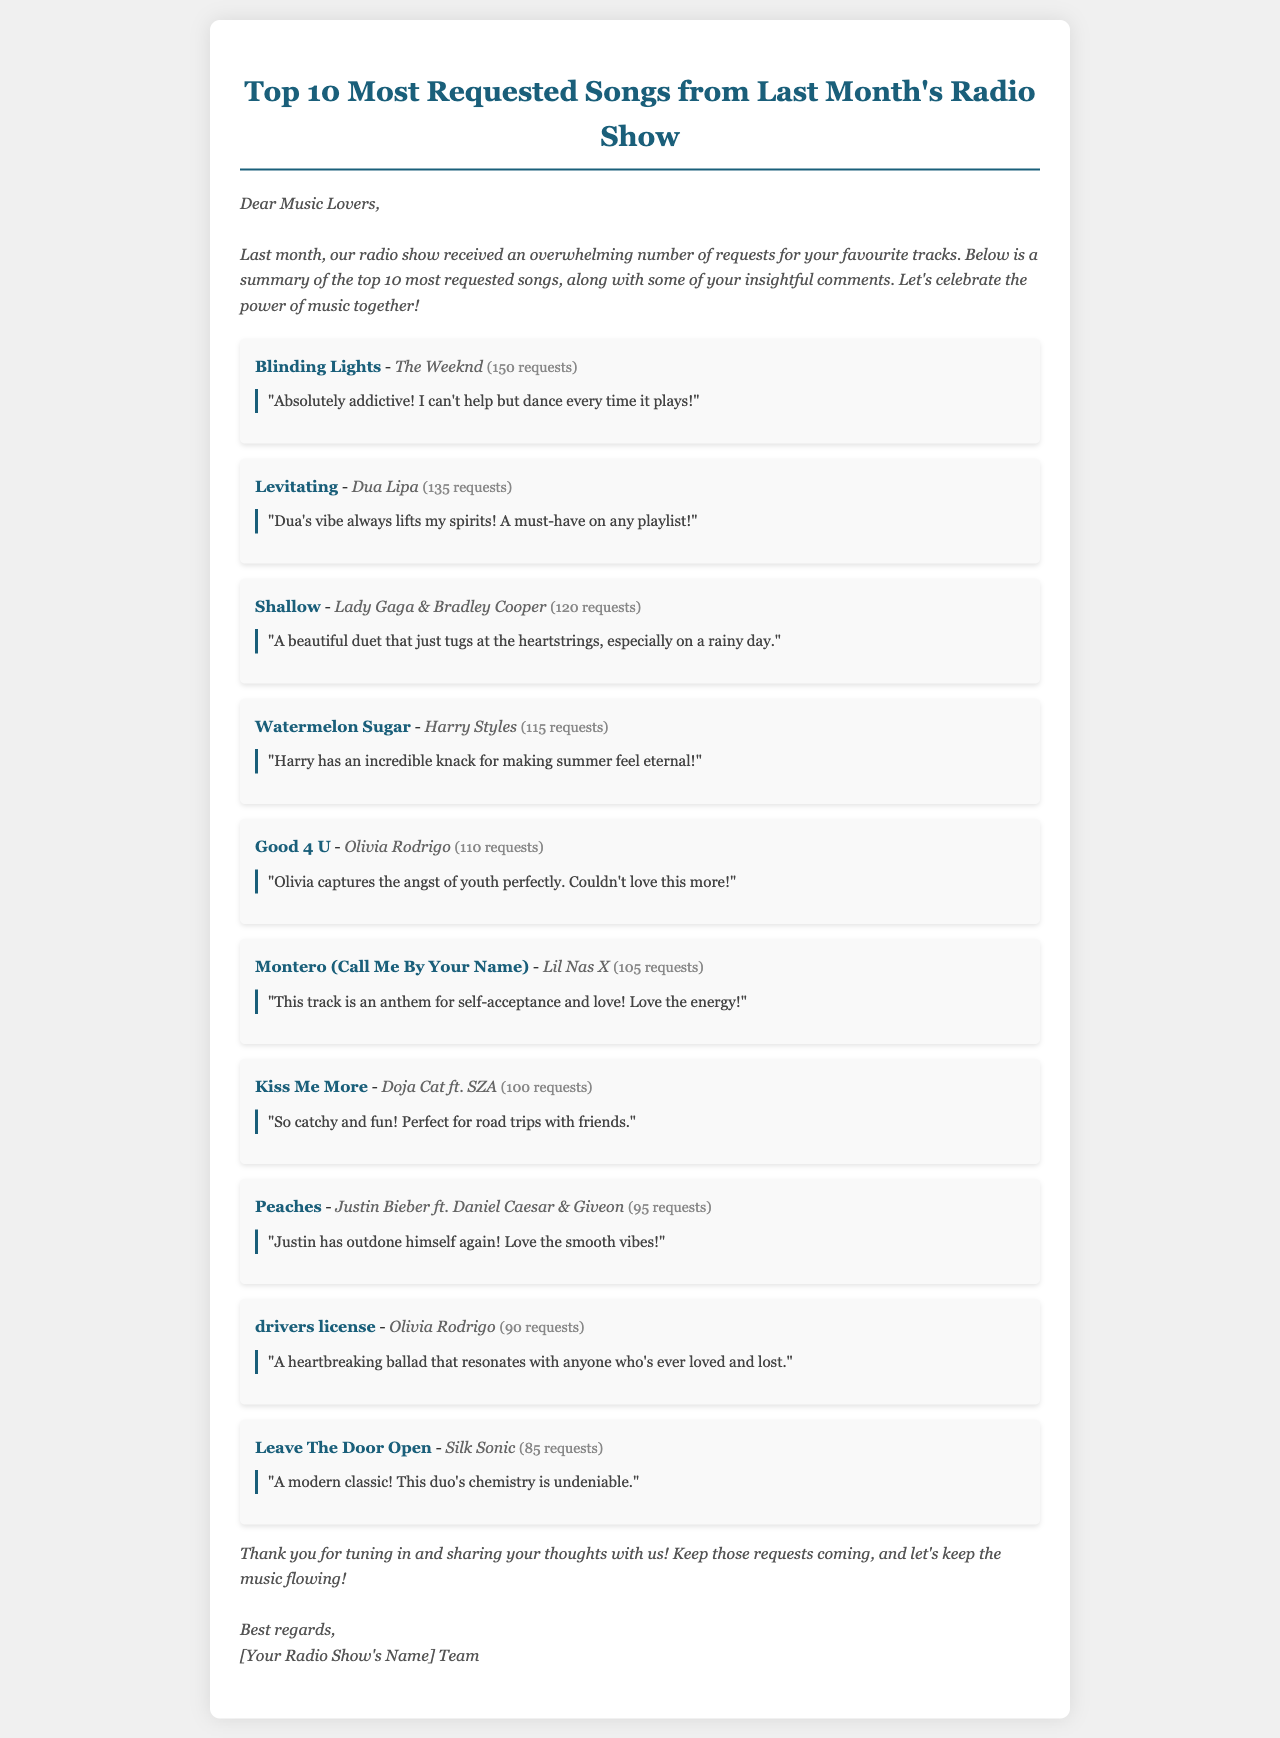What is the title of the document? The title is stated in the heading of the document, which summarizes its content regarding the most requested songs.
Answer: Top 10 Most Requested Songs from Last Month's Radio Show Who is the artist of the song "Watermelon Sugar"? The document lists the artist associated with each song, providing clarity on the performers.
Answer: Harry Styles How many requests did "Shallow" receive? The number of requests is given in parentheses next to each song, indicating popularity.
Answer: 120 requests Which song received the most requests? By comparing the request counts provided for each song, we can determine which one topped the list.
Answer: Blinding Lights What did the listener say about "Levitating"? The document includes listener comments that express opinions about each song, reflecting their feelings.
Answer: "Dua's vibe always lifts my spirits! A must-have on any playlist!" How many songs did Olivia Rodrigo have in the top 10? The song list shows that some artists may appear more than once, requiring a count for accuracy.
Answer: 2 songs What is the overall tone of the document? The introduction and comments indicate the type of sentiments expressed throughout the document, revealing the author's intent.
Answer: Celebratory How does the document engage with the listeners? The document directly addresses the listeners in a welcoming manner, fostering a sense of community around music.
Answer: Acknowledgement and appreciation What is the total number of requests for "drivers license"? The request count for each song provides specific data on listener engagement with the music.
Answer: 90 requests 